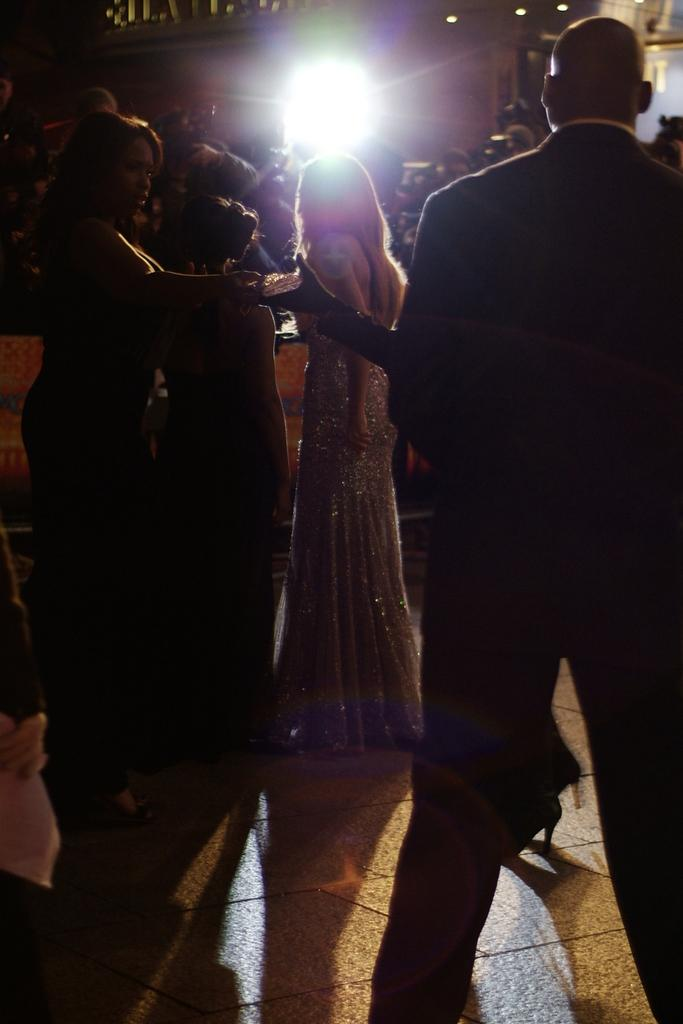What can be seen in the image? There are people standing in the image. Can you describe any other elements in the image? Yes, there is a light visible in the image. What type of kitten is featured in the history of the image? There is no kitten or reference to history in the image; it simply features people standing and a light. 